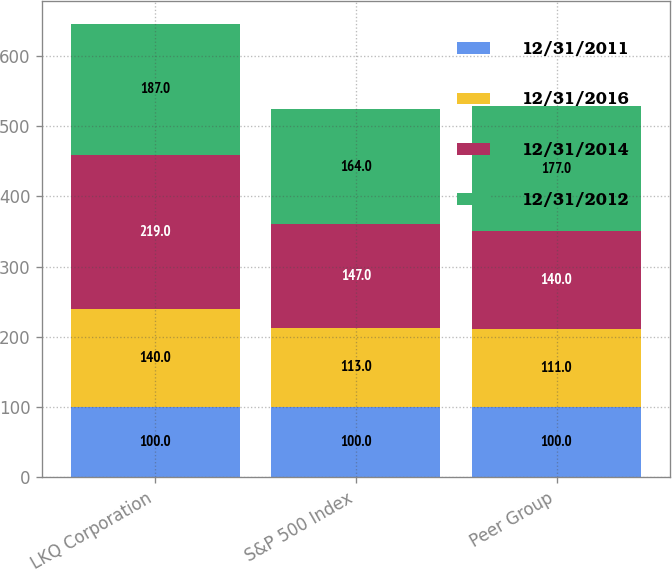Convert chart. <chart><loc_0><loc_0><loc_500><loc_500><stacked_bar_chart><ecel><fcel>LKQ Corporation<fcel>S&P 500 Index<fcel>Peer Group<nl><fcel>12/31/2011<fcel>100<fcel>100<fcel>100<nl><fcel>12/31/2016<fcel>140<fcel>113<fcel>111<nl><fcel>12/31/2014<fcel>219<fcel>147<fcel>140<nl><fcel>12/31/2012<fcel>187<fcel>164<fcel>177<nl></chart> 